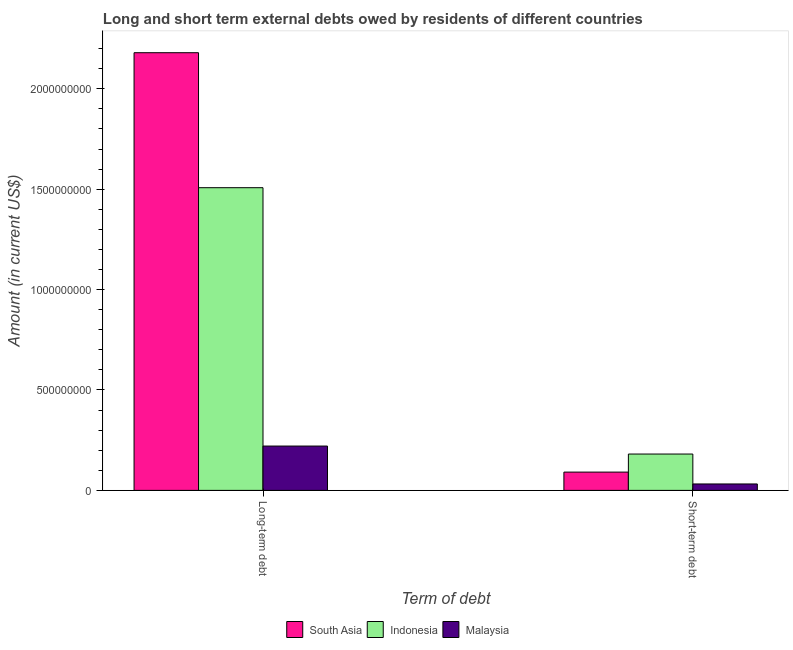Are the number of bars on each tick of the X-axis equal?
Provide a succinct answer. Yes. How many bars are there on the 2nd tick from the left?
Offer a very short reply. 3. What is the label of the 1st group of bars from the left?
Ensure brevity in your answer.  Long-term debt. What is the long-term debts owed by residents in Indonesia?
Provide a short and direct response. 1.51e+09. Across all countries, what is the maximum long-term debts owed by residents?
Your answer should be very brief. 2.18e+09. Across all countries, what is the minimum long-term debts owed by residents?
Provide a short and direct response. 2.21e+08. In which country was the short-term debts owed by residents minimum?
Your answer should be very brief. Malaysia. What is the total long-term debts owed by residents in the graph?
Ensure brevity in your answer.  3.91e+09. What is the difference between the long-term debts owed by residents in Malaysia and that in South Asia?
Give a very brief answer. -1.96e+09. What is the difference between the short-term debts owed by residents in Indonesia and the long-term debts owed by residents in South Asia?
Give a very brief answer. -2.00e+09. What is the average long-term debts owed by residents per country?
Provide a succinct answer. 1.30e+09. What is the difference between the long-term debts owed by residents and short-term debts owed by residents in Malaysia?
Your answer should be very brief. 1.89e+08. What is the ratio of the short-term debts owed by residents in Malaysia to that in Indonesia?
Offer a very short reply. 0.18. What does the 1st bar from the right in Short-term debt represents?
Your response must be concise. Malaysia. How many countries are there in the graph?
Ensure brevity in your answer.  3. Are the values on the major ticks of Y-axis written in scientific E-notation?
Give a very brief answer. No. Does the graph contain any zero values?
Make the answer very short. No. Does the graph contain grids?
Give a very brief answer. No. Where does the legend appear in the graph?
Your answer should be very brief. Bottom center. What is the title of the graph?
Make the answer very short. Long and short term external debts owed by residents of different countries. Does "Iran" appear as one of the legend labels in the graph?
Your response must be concise. No. What is the label or title of the X-axis?
Give a very brief answer. Term of debt. What is the Amount (in current US$) of South Asia in Long-term debt?
Ensure brevity in your answer.  2.18e+09. What is the Amount (in current US$) in Indonesia in Long-term debt?
Your response must be concise. 1.51e+09. What is the Amount (in current US$) in Malaysia in Long-term debt?
Your answer should be very brief. 2.21e+08. What is the Amount (in current US$) of South Asia in Short-term debt?
Offer a very short reply. 9.10e+07. What is the Amount (in current US$) of Indonesia in Short-term debt?
Make the answer very short. 1.81e+08. What is the Amount (in current US$) in Malaysia in Short-term debt?
Your answer should be very brief. 3.20e+07. Across all Term of debt, what is the maximum Amount (in current US$) in South Asia?
Your response must be concise. 2.18e+09. Across all Term of debt, what is the maximum Amount (in current US$) of Indonesia?
Your response must be concise. 1.51e+09. Across all Term of debt, what is the maximum Amount (in current US$) of Malaysia?
Keep it short and to the point. 2.21e+08. Across all Term of debt, what is the minimum Amount (in current US$) of South Asia?
Provide a succinct answer. 9.10e+07. Across all Term of debt, what is the minimum Amount (in current US$) in Indonesia?
Make the answer very short. 1.81e+08. Across all Term of debt, what is the minimum Amount (in current US$) in Malaysia?
Make the answer very short. 3.20e+07. What is the total Amount (in current US$) of South Asia in the graph?
Offer a terse response. 2.27e+09. What is the total Amount (in current US$) in Indonesia in the graph?
Offer a terse response. 1.69e+09. What is the total Amount (in current US$) of Malaysia in the graph?
Your answer should be very brief. 2.53e+08. What is the difference between the Amount (in current US$) in South Asia in Long-term debt and that in Short-term debt?
Give a very brief answer. 2.09e+09. What is the difference between the Amount (in current US$) in Indonesia in Long-term debt and that in Short-term debt?
Give a very brief answer. 1.33e+09. What is the difference between the Amount (in current US$) in Malaysia in Long-term debt and that in Short-term debt?
Provide a succinct answer. 1.89e+08. What is the difference between the Amount (in current US$) of South Asia in Long-term debt and the Amount (in current US$) of Indonesia in Short-term debt?
Your answer should be compact. 2.00e+09. What is the difference between the Amount (in current US$) of South Asia in Long-term debt and the Amount (in current US$) of Malaysia in Short-term debt?
Provide a short and direct response. 2.15e+09. What is the difference between the Amount (in current US$) of Indonesia in Long-term debt and the Amount (in current US$) of Malaysia in Short-term debt?
Keep it short and to the point. 1.48e+09. What is the average Amount (in current US$) of South Asia per Term of debt?
Keep it short and to the point. 1.14e+09. What is the average Amount (in current US$) in Indonesia per Term of debt?
Keep it short and to the point. 8.44e+08. What is the average Amount (in current US$) of Malaysia per Term of debt?
Your response must be concise. 1.26e+08. What is the difference between the Amount (in current US$) of South Asia and Amount (in current US$) of Indonesia in Long-term debt?
Keep it short and to the point. 6.72e+08. What is the difference between the Amount (in current US$) of South Asia and Amount (in current US$) of Malaysia in Long-term debt?
Keep it short and to the point. 1.96e+09. What is the difference between the Amount (in current US$) of Indonesia and Amount (in current US$) of Malaysia in Long-term debt?
Provide a succinct answer. 1.29e+09. What is the difference between the Amount (in current US$) of South Asia and Amount (in current US$) of Indonesia in Short-term debt?
Keep it short and to the point. -9.00e+07. What is the difference between the Amount (in current US$) in South Asia and Amount (in current US$) in Malaysia in Short-term debt?
Make the answer very short. 5.90e+07. What is the difference between the Amount (in current US$) of Indonesia and Amount (in current US$) of Malaysia in Short-term debt?
Ensure brevity in your answer.  1.49e+08. What is the ratio of the Amount (in current US$) in South Asia in Long-term debt to that in Short-term debt?
Your answer should be compact. 23.95. What is the ratio of the Amount (in current US$) of Indonesia in Long-term debt to that in Short-term debt?
Provide a short and direct response. 8.33. What is the ratio of the Amount (in current US$) of Malaysia in Long-term debt to that in Short-term debt?
Your answer should be very brief. 6.9. What is the difference between the highest and the second highest Amount (in current US$) of South Asia?
Keep it short and to the point. 2.09e+09. What is the difference between the highest and the second highest Amount (in current US$) in Indonesia?
Your answer should be compact. 1.33e+09. What is the difference between the highest and the second highest Amount (in current US$) in Malaysia?
Give a very brief answer. 1.89e+08. What is the difference between the highest and the lowest Amount (in current US$) of South Asia?
Give a very brief answer. 2.09e+09. What is the difference between the highest and the lowest Amount (in current US$) of Indonesia?
Your answer should be very brief. 1.33e+09. What is the difference between the highest and the lowest Amount (in current US$) in Malaysia?
Keep it short and to the point. 1.89e+08. 